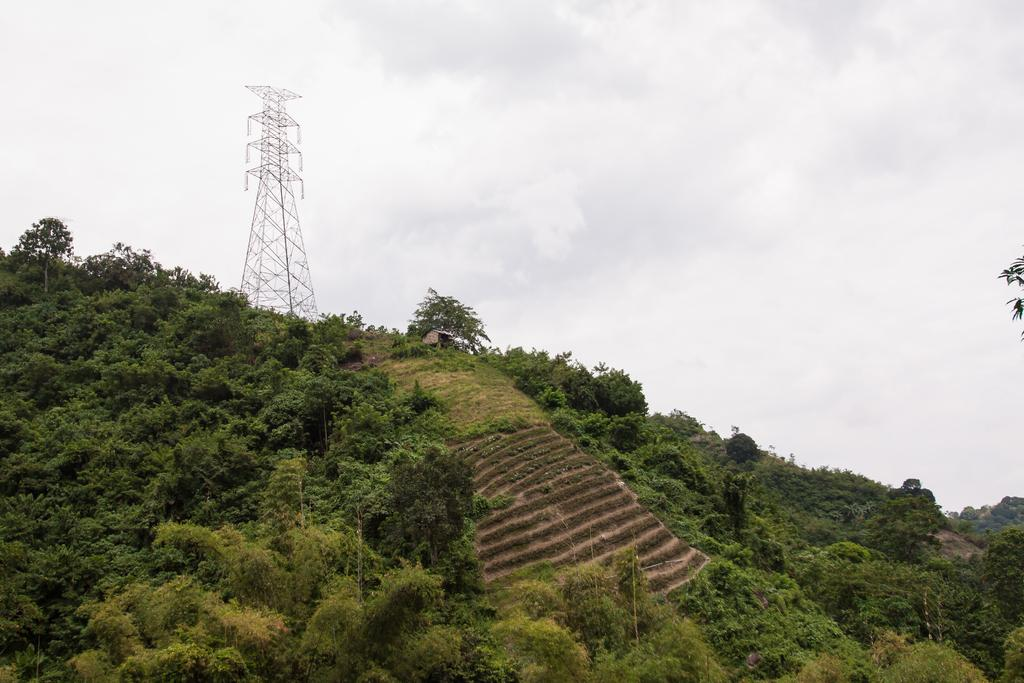What type of natural formation can be seen in the image? There are mountains in the image. What man-made structure is present in the image? There is a tower in the image. What is the condition of the sky in the image? The sky is cloudy in the image. Who is the owner of the bell in the image? There is no bell present in the image. What type of sponge can be seen growing on the mountains in the image? There are no sponges visible on the mountains in the image. 